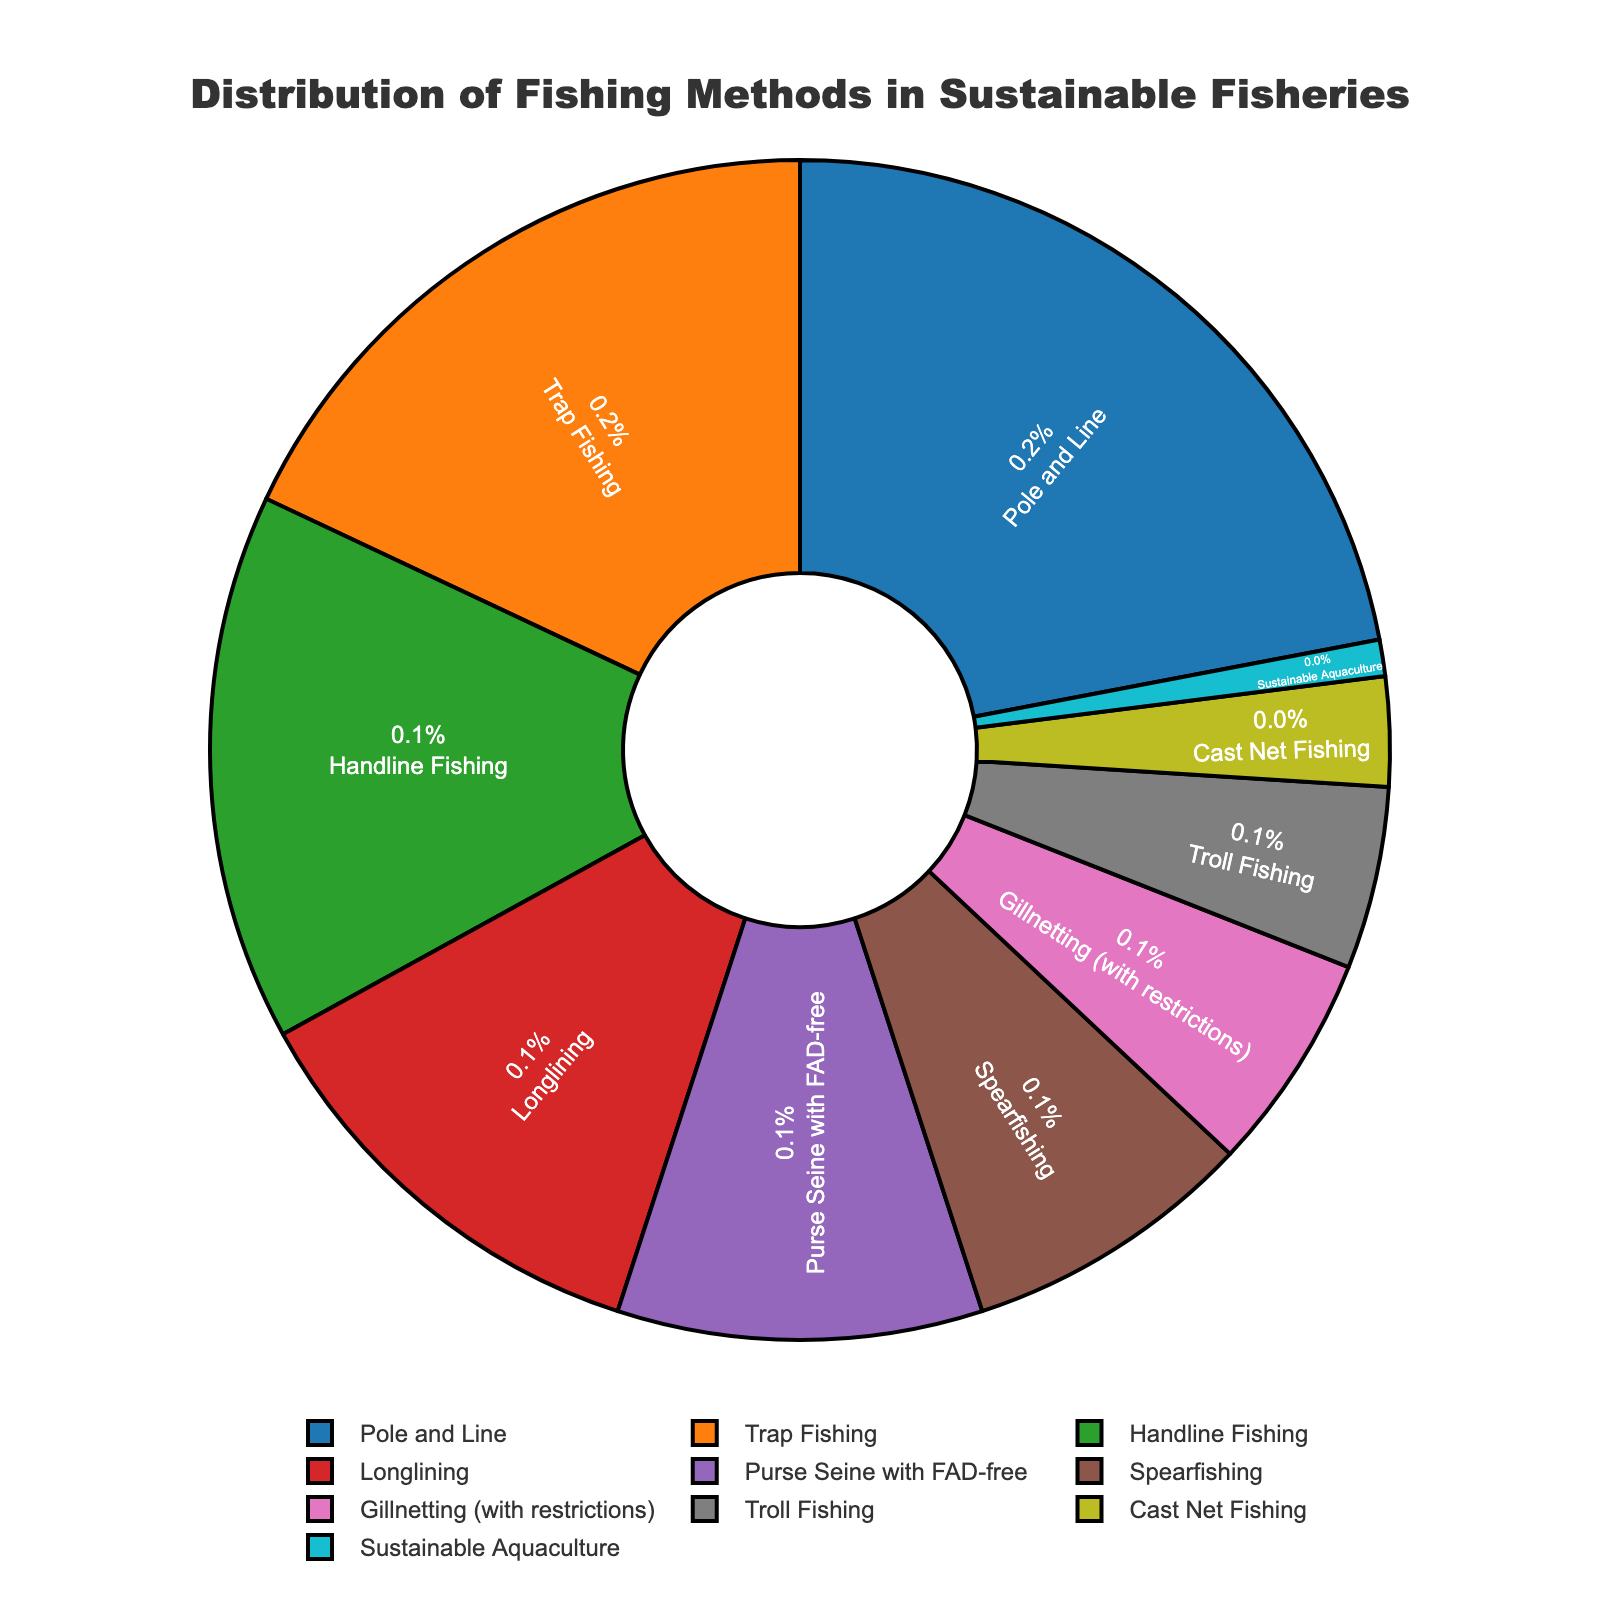What fishing method has the highest percentage? The segment labeled "Pole and Line" has the highest percentage value shown within the pie chart.
Answer: Pole and Line How much more percentage does Pole and Line have compared to Trap Fishing? Pole and Line is 22%, and Trap Fishing is 18%. Subtracting these gives 22% - 18% = 4%.
Answer: 4% What are the combined percentages of sustainable fishing methods that make up less than 10% each? Add the percentages of Spearfishing (8%), Gillnetting (6%), Troll Fishing (5%), Cast Net Fishing (3%), and Sustainable Aquaculture (1%). Summing these gives 8% + 6% + 5% + 3% + 1% = 23%.
Answer: 23% Which methods constitute more than 15% of the total? The methods with percentages larger than 15% in the chart are Pole and Line (22%) and Trap Fishing (18%).
Answer: Pole and Line, Trap Fishing Is the percentage of Pole and Line larger than the combined percentage of Handline Fishing and Longlining? The percentage for Pole and Line is 22%. The combined percentage of Handline Fishing and Longlining is 15% + 12% = 27%. Thus, 22% is not larger than 27%.
Answer: No What is the difference in percentage between Purse Seine with FAD-free and Spearfishing? The percentage for Purse Seine with FAD-free is 10%, and for Spearfishing is 8%. The difference is 10% - 8% = 2%.
Answer: 2% Are there more methods that fall below or above the threshold of 10%? Methods above 10%: Pole and Line (22%), Trap Fishing (18%), Handline Fishing (15%), and Longlining (12%) comprise four methods. Methods below 10%: Purse Seine with FAD-free (10%), Spearfishing (8%), Gillnetting (6%), Troll Fishing (5%), Cast Net Fishing (3%), and Sustainable Aquaculture (1%) comprise six methods. Thus, more methods fall below the threshold.
Answer: Below What percentage of the total is represented by the two least utilized fishing methods? The two least utilized fishing methods are Cast Net Fishing (3%) and Sustainable Aquaculture (1%). Summing these gives 3% + 1% = 4%.
Answer: 4% Which fishing method is visually represented in the purplish (brown or purple) color in the pie chart? The purplish-colored segment corresponds to the label "Sustainable Aquaculture" based on the visual distinction in the pie chart.
Answer: Sustainable Aquaculture What is the approximate average percentage of the methods that fall between 5% and 10%? Methods between 5% and 10%: Gillnetting (6%), Troll Fishing (5%), and Purse Seine with FAD-free (10%). Summing these gives 6% + 5% + 10% = 21%. There are three methods, so the average is 21% / 3 = 7%.
Answer: 7% 